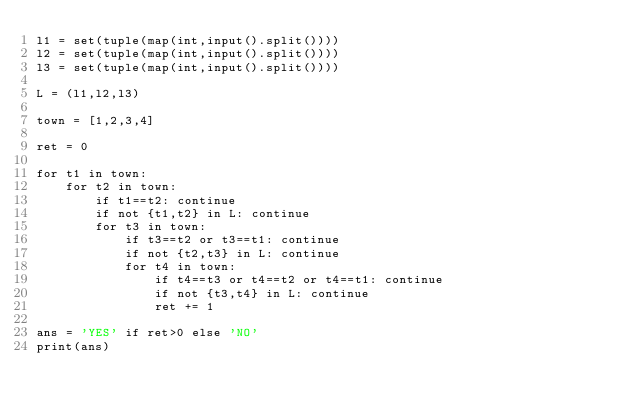<code> <loc_0><loc_0><loc_500><loc_500><_Python_>l1 = set(tuple(map(int,input().split())))
l2 = set(tuple(map(int,input().split())))
l3 = set(tuple(map(int,input().split())))

L = (l1,l2,l3)

town = [1,2,3,4]

ret = 0

for t1 in town:
    for t2 in town:
        if t1==t2: continue
        if not {t1,t2} in L: continue
        for t3 in town:
            if t3==t2 or t3==t1: continue
            if not {t2,t3} in L: continue
            for t4 in town:
                if t4==t3 or t4==t2 or t4==t1: continue
                if not {t3,t4} in L: continue
                ret += 1

ans = 'YES' if ret>0 else 'NO'
print(ans)

</code> 